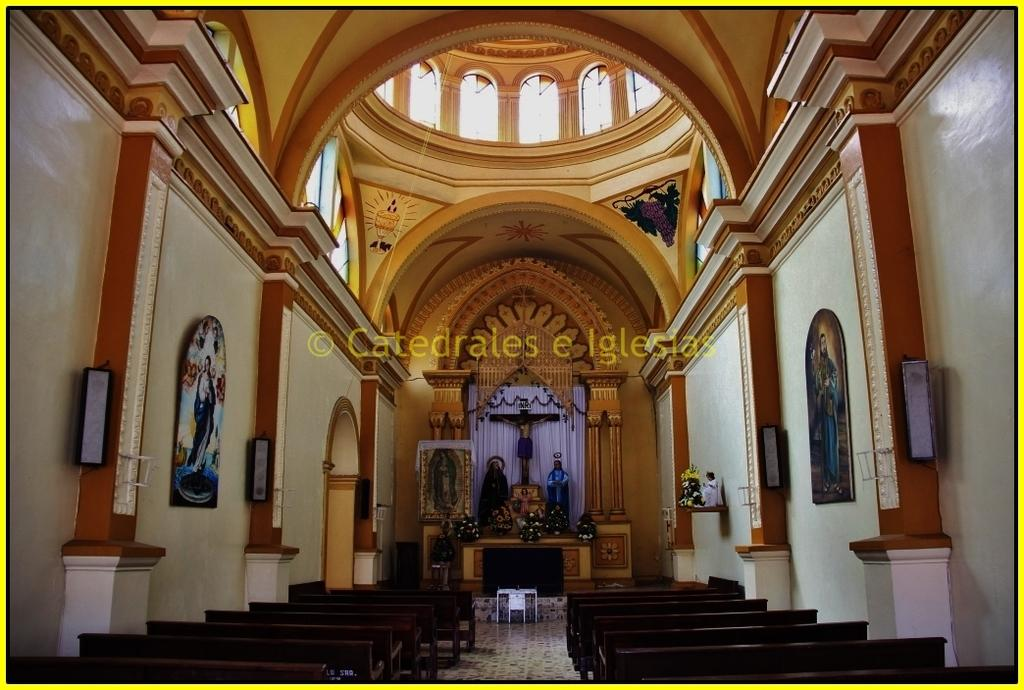What type of furniture is on the floor in the image? There are benches on the floor in the image. What architectural elements can be seen in the image? There are pillars in the image. What devices are present for sound amplification? There are speakers in the image. What decorative items are on the wall in the image? There are frames on the wall in the image. What type of window treatment is present in the image? There are curtains in the image. What type of artwork or decoration is present in the image? There are statues in the image. What type of natural elements are present in the image? There are flowers in the image. What part of the room is visible in the image? There is a ceiling in the image. What type of text is visible in the image? There is some text visible in the image. How many tomatoes are hanging from the ceiling in the image? There are no tomatoes present in the image; the ceiling is visible, but no tomatoes are hanging from it. What type of tin object can be seen in the image? There is no tin object present in the image. 